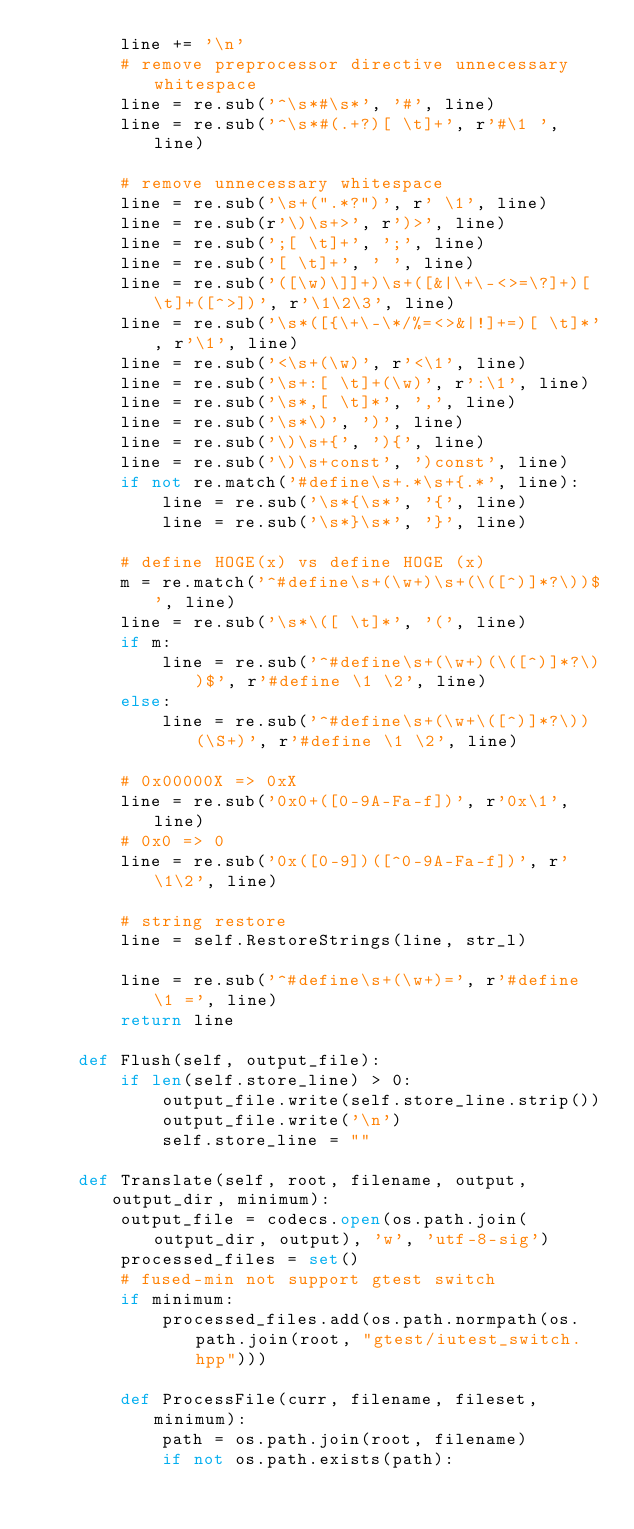Convert code to text. <code><loc_0><loc_0><loc_500><loc_500><_Python_>        line += '\n'
        # remove preprocessor directive unnecessary whitespace
        line = re.sub('^\s*#\s*', '#', line)
        line = re.sub('^\s*#(.+?)[ \t]+', r'#\1 ', line)

        # remove unnecessary whitespace
        line = re.sub('\s+(".*?")', r' \1', line)
        line = re.sub(r'\)\s+>', r')>', line)
        line = re.sub(';[ \t]+', ';', line)
        line = re.sub('[ \t]+', ' ', line)
        line = re.sub('([\w)\]]+)\s+([&|\+\-<>=\?]+)[ \t]+([^>])', r'\1\2\3', line)
        line = re.sub('\s*([{\+\-\*/%=<>&|!]+=)[ \t]*', r'\1', line)
        line = re.sub('<\s+(\w)', r'<\1', line)
        line = re.sub('\s+:[ \t]+(\w)', r':\1', line)
        line = re.sub('\s*,[ \t]*', ',', line)
        line = re.sub('\s*\)', ')', line)
        line = re.sub('\)\s+{', '){', line)
        line = re.sub('\)\s+const', ')const', line)
        if not re.match('#define\s+.*\s+{.*', line):
            line = re.sub('\s*{\s*', '{', line)
            line = re.sub('\s*}\s*', '}', line)

        # define HOGE(x) vs define HOGE (x)
        m = re.match('^#define\s+(\w+)\s+(\([^)]*?\))$', line)
        line = re.sub('\s*\([ \t]*', '(', line)
        if m:
            line = re.sub('^#define\s+(\w+)(\([^)]*?\))$', r'#define \1 \2', line)
        else:
            line = re.sub('^#define\s+(\w+\([^)]*?\))(\S+)', r'#define \1 \2', line)

        # 0x00000X => 0xX
        line = re.sub('0x0+([0-9A-Fa-f])', r'0x\1', line)
        # 0x0 => 0
        line = re.sub('0x([0-9])([^0-9A-Fa-f])', r'\1\2', line)

        # string restore
        line = self.RestoreStrings(line, str_l)

        line = re.sub('^#define\s+(\w+)=', r'#define \1 =', line)
        return line

    def Flush(self, output_file):
        if len(self.store_line) > 0:
            output_file.write(self.store_line.strip())
            output_file.write('\n')
            self.store_line = ""

    def Translate(self, root, filename, output, output_dir, minimum):
        output_file = codecs.open(os.path.join(output_dir, output), 'w', 'utf-8-sig')
        processed_files = set()
        # fused-min not support gtest switch
        if minimum:
            processed_files.add(os.path.normpath(os.path.join(root, "gtest/iutest_switch.hpp")))

        def ProcessFile(curr, filename, fileset, minimum):
            path = os.path.join(root, filename)
            if not os.path.exists(path):</code> 